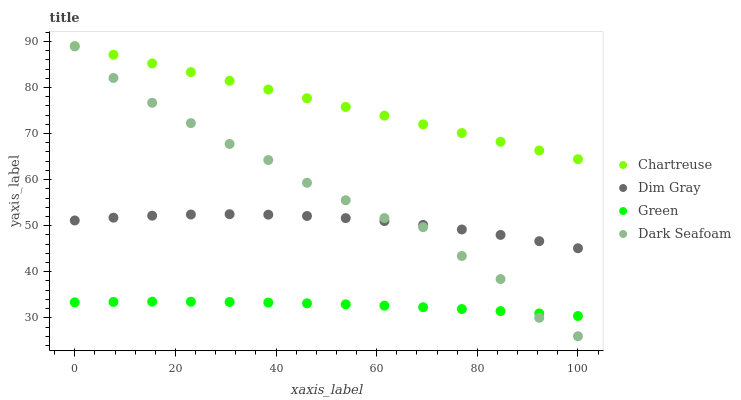Does Green have the minimum area under the curve?
Answer yes or no. Yes. Does Chartreuse have the maximum area under the curve?
Answer yes or no. Yes. Does Dim Gray have the minimum area under the curve?
Answer yes or no. No. Does Dim Gray have the maximum area under the curve?
Answer yes or no. No. Is Chartreuse the smoothest?
Answer yes or no. Yes. Is Dark Seafoam the roughest?
Answer yes or no. Yes. Is Dim Gray the smoothest?
Answer yes or no. No. Is Dim Gray the roughest?
Answer yes or no. No. Does Dark Seafoam have the lowest value?
Answer yes or no. Yes. Does Dim Gray have the lowest value?
Answer yes or no. No. Does Chartreuse have the highest value?
Answer yes or no. Yes. Does Dim Gray have the highest value?
Answer yes or no. No. Is Green less than Dim Gray?
Answer yes or no. Yes. Is Chartreuse greater than Dark Seafoam?
Answer yes or no. Yes. Does Dark Seafoam intersect Dim Gray?
Answer yes or no. Yes. Is Dark Seafoam less than Dim Gray?
Answer yes or no. No. Is Dark Seafoam greater than Dim Gray?
Answer yes or no. No. Does Green intersect Dim Gray?
Answer yes or no. No. 